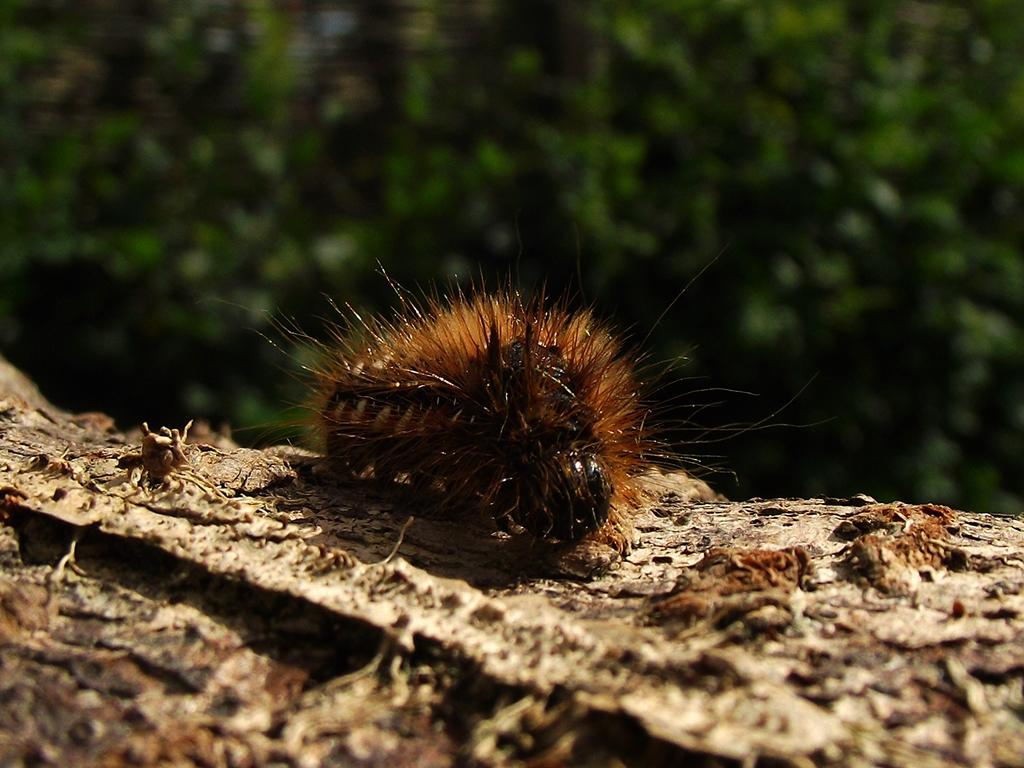What is the main subject in the foreground of the image? There is an insect in the foreground of the image. What type of surface is the insect on? The insect is on a wooden surface. What can be seen in the background of the image? There is greenery in the background of the image. What type of liquid is being poured by the minister in the image? There is no minister or liquid present in the image; it features an insect on a wooden surface with greenery in the background. 